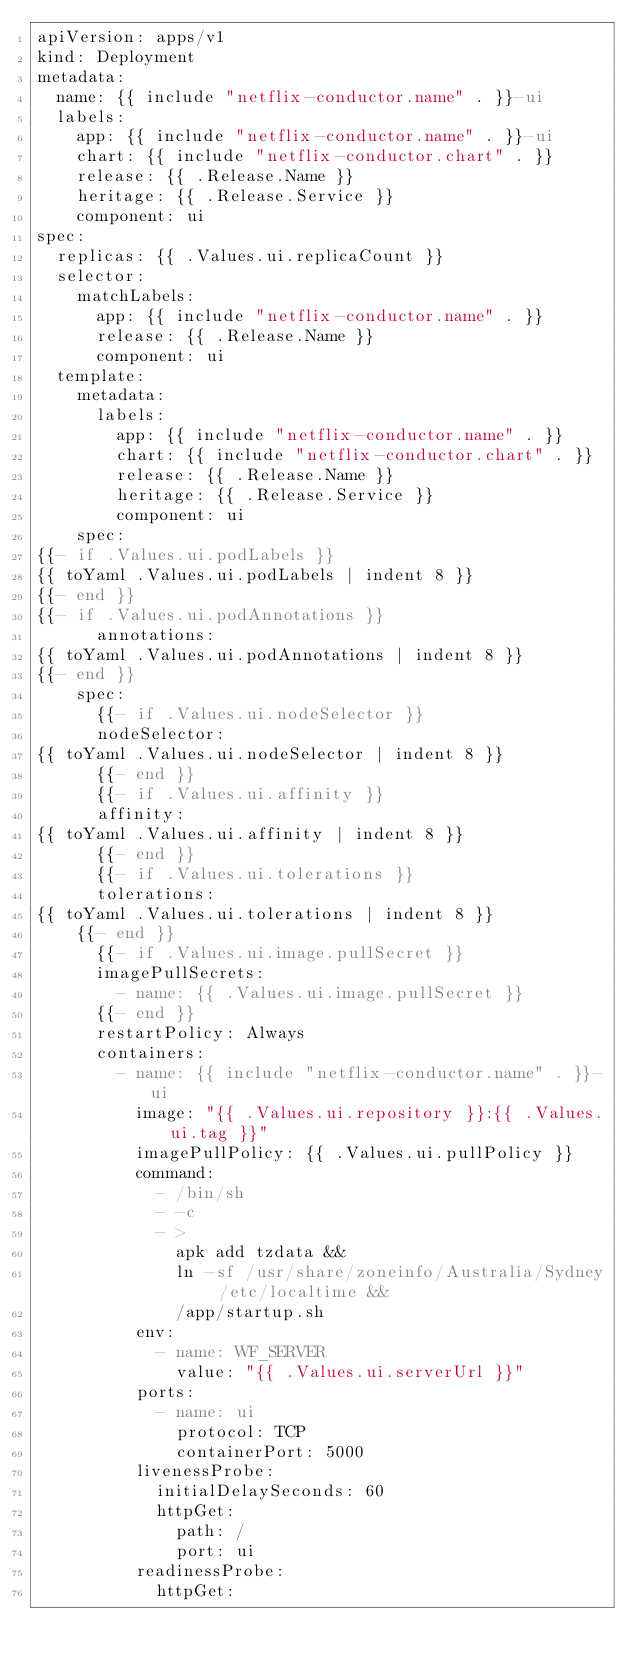<code> <loc_0><loc_0><loc_500><loc_500><_YAML_>apiVersion: apps/v1
kind: Deployment
metadata:
  name: {{ include "netflix-conductor.name" . }}-ui
  labels:
    app: {{ include "netflix-conductor.name" . }}-ui
    chart: {{ include "netflix-conductor.chart" . }}
    release: {{ .Release.Name }}
    heritage: {{ .Release.Service }}
    component: ui
spec:
  replicas: {{ .Values.ui.replicaCount }}
  selector:
    matchLabels:
      app: {{ include "netflix-conductor.name" . }}
      release: {{ .Release.Name }}
      component: ui
  template:
    metadata:
      labels:
        app: {{ include "netflix-conductor.name" . }}
        chart: {{ include "netflix-conductor.chart" . }}
        release: {{ .Release.Name }}
        heritage: {{ .Release.Service }}
        component: ui
    spec:
{{- if .Values.ui.podLabels }}
{{ toYaml .Values.ui.podLabels | indent 8 }}
{{- end }}
{{- if .Values.ui.podAnnotations }}
      annotations:
{{ toYaml .Values.ui.podAnnotations | indent 8 }}
{{- end }}
    spec:
      {{- if .Values.ui.nodeSelector }}
      nodeSelector:
{{ toYaml .Values.ui.nodeSelector | indent 8 }}
      {{- end }}
      {{- if .Values.ui.affinity }}
      affinity:
{{ toYaml .Values.ui.affinity | indent 8 }}
      {{- end }}
      {{- if .Values.ui.tolerations }}
      tolerations:
{{ toYaml .Values.ui.tolerations | indent 8 }}
    {{- end }}
      {{- if .Values.ui.image.pullSecret }}
      imagePullSecrets:
        - name: {{ .Values.ui.image.pullSecret }}
      {{- end }}
      restartPolicy: Always
      containers:
        - name: {{ include "netflix-conductor.name" . }}-ui
          image: "{{ .Values.ui.repository }}:{{ .Values.ui.tag }}"
          imagePullPolicy: {{ .Values.ui.pullPolicy }}
          command:
            - /bin/sh
            - -c
            - >
              apk add tzdata &&
              ln -sf /usr/share/zoneinfo/Australia/Sydney /etc/localtime &&
              /app/startup.sh
          env:
            - name: WF_SERVER
              value: "{{ .Values.ui.serverUrl }}"
          ports:
            - name: ui
              protocol: TCP
              containerPort: 5000
          livenessProbe:
            initialDelaySeconds: 60
            httpGet:
              path: /
              port: ui
          readinessProbe:
            httpGet:</code> 